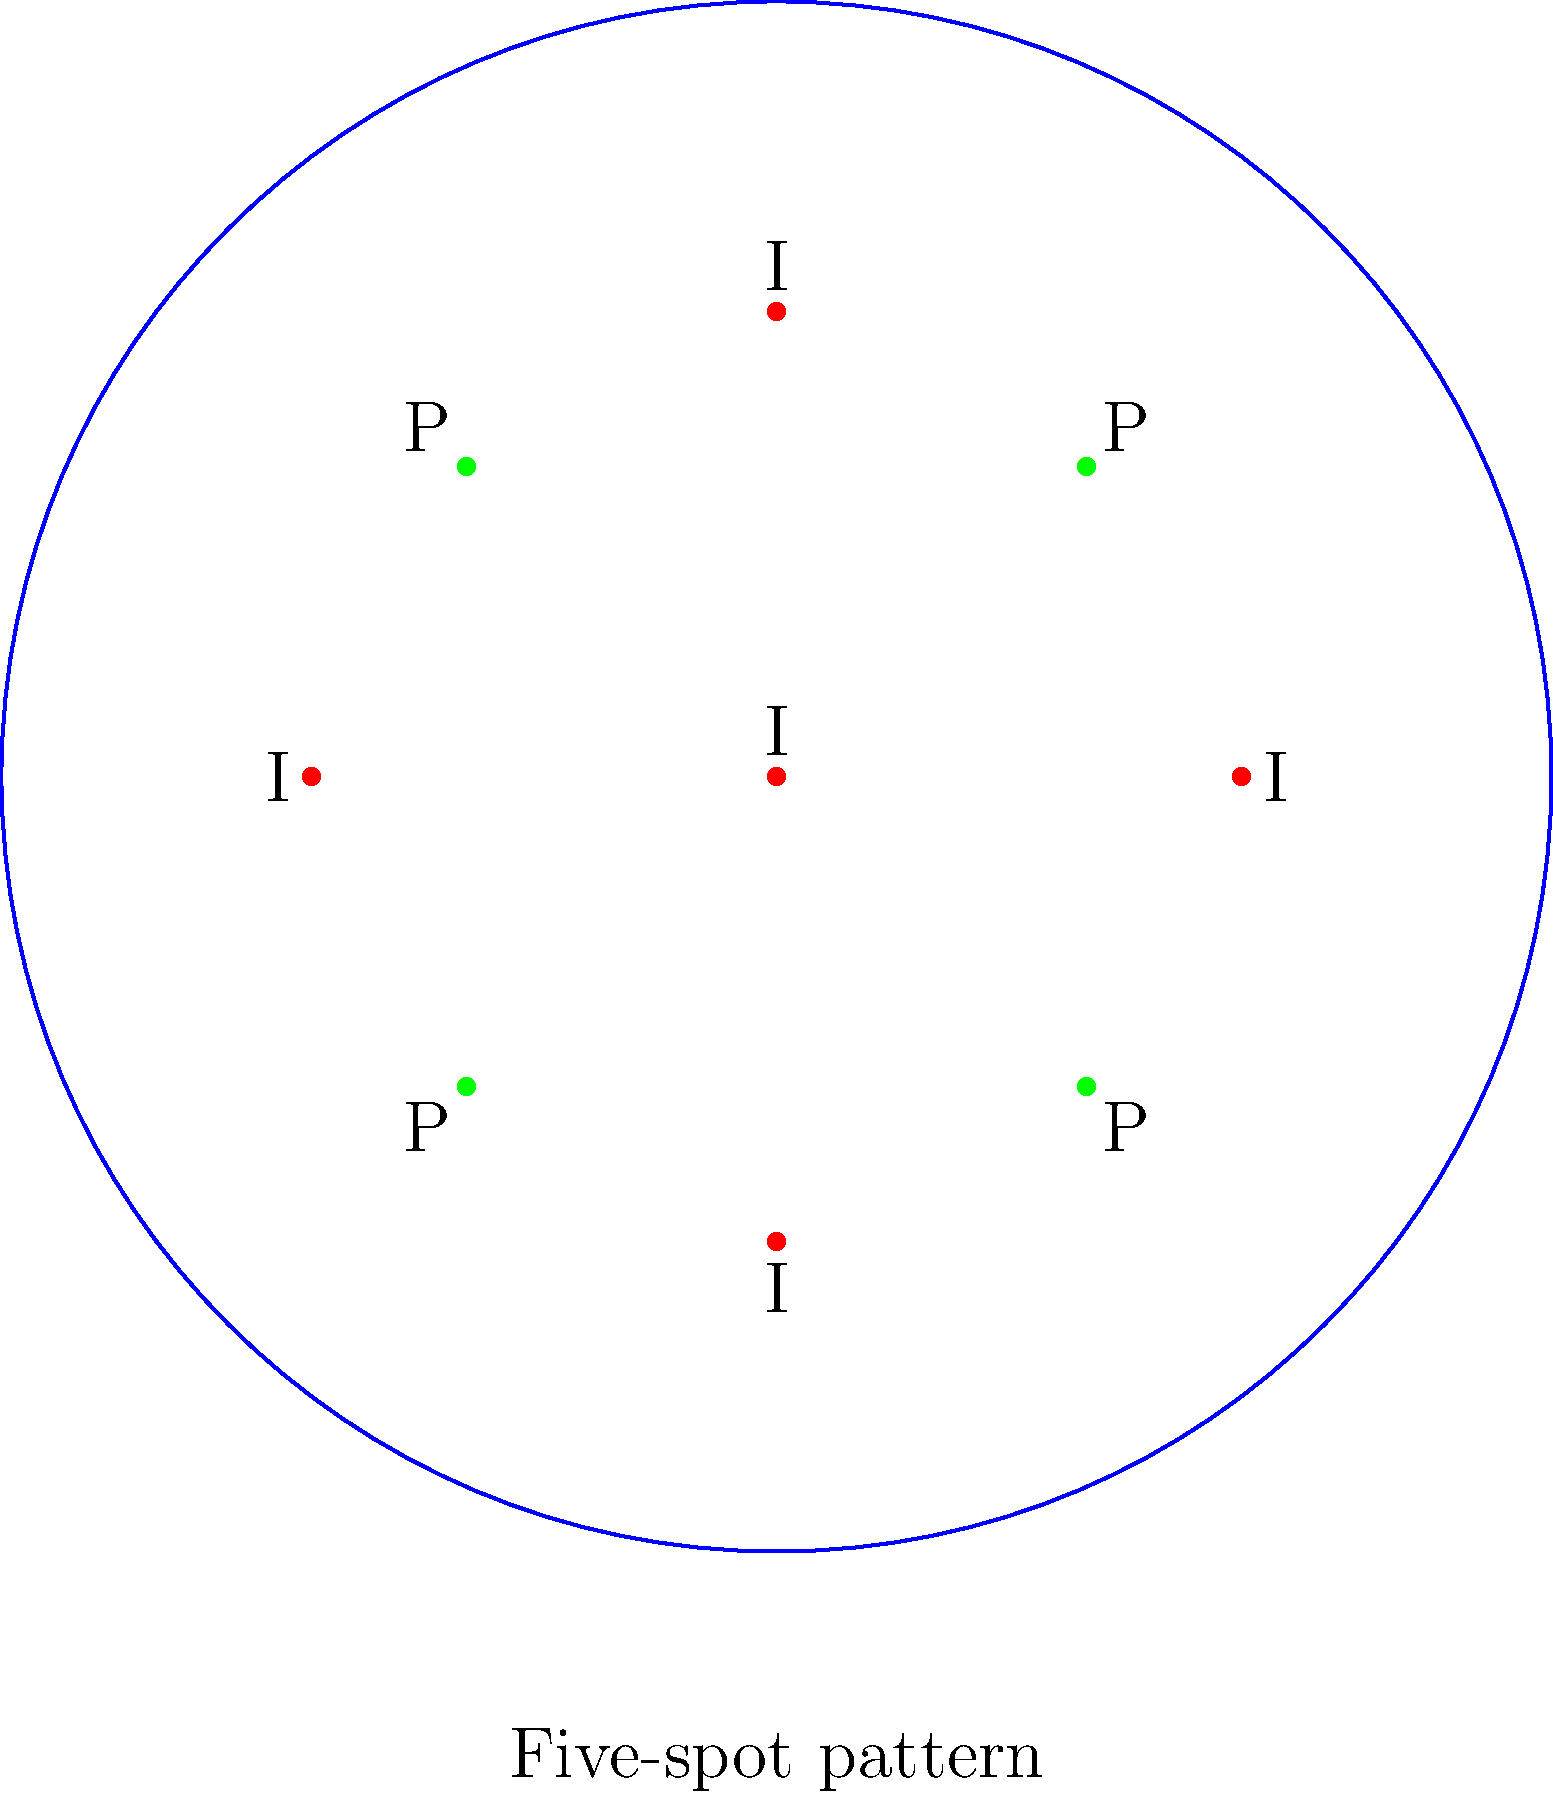In the oil reservoir diagram shown above, a five-spot injection pattern is illustrated. If the reservoir has a uniform permeability and the injection rate is constant for all injection wells, which production well(s) will likely have the highest oil recovery rate? Explain your reasoning. To determine which production well(s) will likely have the highest oil recovery rate, we need to consider the following factors:

1. Injection pattern: The diagram shows a five-spot injection pattern, with four injection wells (I) at the corners of a square and one in the center.

2. Production well locations: Four production wells (P) are located at the midpoints of the sides of the square formed by the corner injection wells.

3. Uniform permeability: The reservoir has uniform permeability, meaning fluid flow will be equally resistant in all directions.

4. Constant injection rate: All injection wells have the same injection rate.

Given these conditions, we can analyze the flow patterns:

5. Central injection well: The central injection well will distribute fluid equally in all directions due to uniform permeability.

6. Corner injection wells: Each corner injection well will primarily influence its adjacent production wells.

7. Superposition of flow: The flow from all injection wells will combine, creating a more complex flow pattern.

8. Symmetry: Due to the symmetrical arrangement of wells and uniform conditions, all four production wells will experience identical flow patterns.

9. Pressure distribution: The pressure will be highest at the injection wells and lowest at the production wells, creating a symmetrical pressure gradient.

Therefore, considering the symmetry of the pattern and uniform reservoir conditions, all four production wells will likely have the same oil recovery rate. No single well will have a higher rate than the others.
Answer: All production wells will have equal oil recovery rates. 